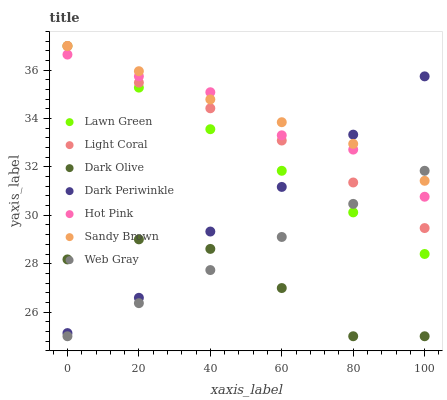Does Dark Olive have the minimum area under the curve?
Answer yes or no. Yes. Does Sandy Brown have the maximum area under the curve?
Answer yes or no. Yes. Does Hot Pink have the minimum area under the curve?
Answer yes or no. No. Does Hot Pink have the maximum area under the curve?
Answer yes or no. No. Is Lawn Green the smoothest?
Answer yes or no. Yes. Is Dark Olive the roughest?
Answer yes or no. Yes. Is Hot Pink the smoothest?
Answer yes or no. No. Is Hot Pink the roughest?
Answer yes or no. No. Does Dark Olive have the lowest value?
Answer yes or no. Yes. Does Hot Pink have the lowest value?
Answer yes or no. No. Does Sandy Brown have the highest value?
Answer yes or no. Yes. Does Hot Pink have the highest value?
Answer yes or no. No. Is Dark Olive less than Hot Pink?
Answer yes or no. Yes. Is Dark Periwinkle greater than Web Gray?
Answer yes or no. Yes. Does Lawn Green intersect Light Coral?
Answer yes or no. Yes. Is Lawn Green less than Light Coral?
Answer yes or no. No. Is Lawn Green greater than Light Coral?
Answer yes or no. No. Does Dark Olive intersect Hot Pink?
Answer yes or no. No. 